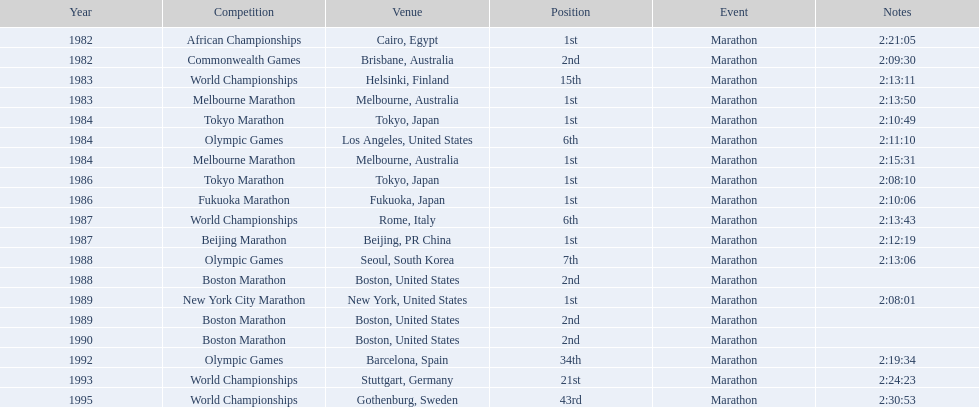What types of competitions exist? African Championships, Cairo, Egypt, Commonwealth Games, Brisbane, Australia, World Championships, Helsinki, Finland, Melbourne Marathon, Melbourne, Australia, Tokyo Marathon, Tokyo, Japan, Olympic Games, Los Angeles, United States, Melbourne Marathon, Melbourne, Australia, Tokyo Marathon, Tokyo, Japan, Fukuoka Marathon, Fukuoka, Japan, World Championships, Rome, Italy, Beijing Marathon, Beijing, PR China, Olympic Games, Seoul, South Korea, Boston Marathon, Boston, United States, New York City Marathon, New York, United States, Boston Marathon, Boston, United States, Boston Marathon, Boston, United States, Olympic Games, Barcelona, Spain, World Championships, Stuttgart, Germany, World Championships, Gothenburg, Sweden. Which ones have occurred in china? Beijing Marathon, Beijing, PR China. Which exact competition is in question? Beijing Marathon. 